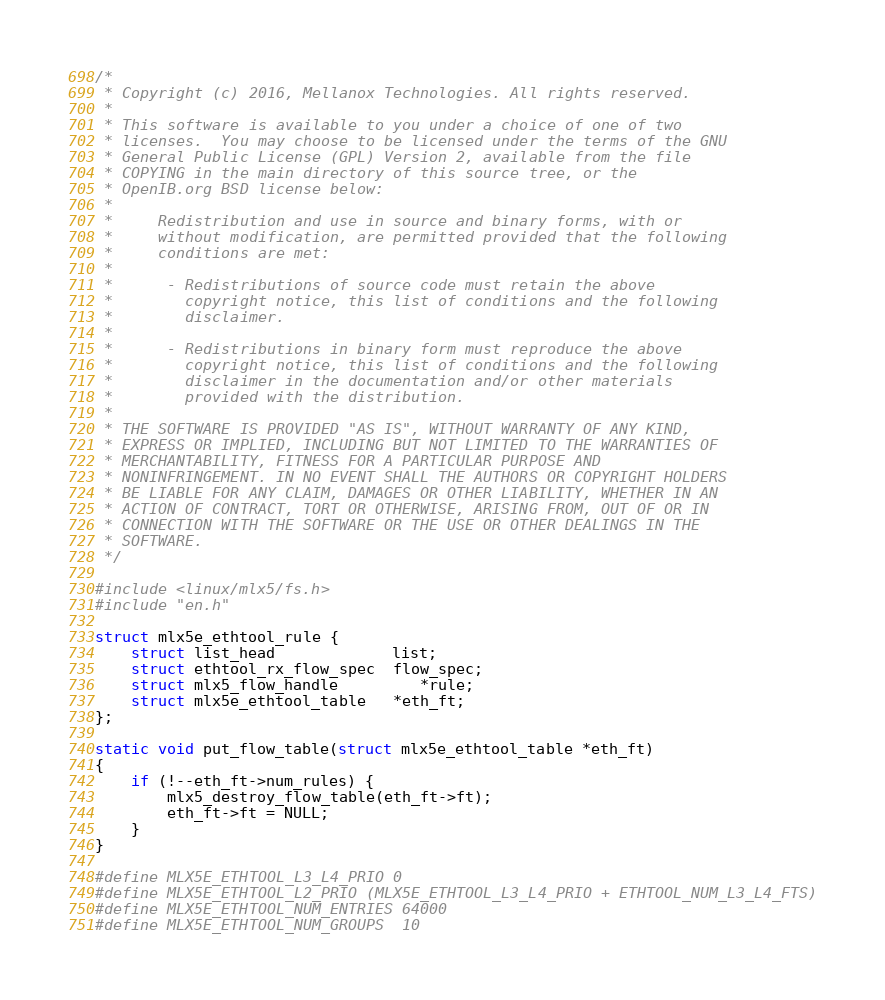Convert code to text. <code><loc_0><loc_0><loc_500><loc_500><_C_>/*
 * Copyright (c) 2016, Mellanox Technologies. All rights reserved.
 *
 * This software is available to you under a choice of one of two
 * licenses.  You may choose to be licensed under the terms of the GNU
 * General Public License (GPL) Version 2, available from the file
 * COPYING in the main directory of this source tree, or the
 * OpenIB.org BSD license below:
 *
 *     Redistribution and use in source and binary forms, with or
 *     without modification, are permitted provided that the following
 *     conditions are met:
 *
 *      - Redistributions of source code must retain the above
 *        copyright notice, this list of conditions and the following
 *        disclaimer.
 *
 *      - Redistributions in binary form must reproduce the above
 *        copyright notice, this list of conditions and the following
 *        disclaimer in the documentation and/or other materials
 *        provided with the distribution.
 *
 * THE SOFTWARE IS PROVIDED "AS IS", WITHOUT WARRANTY OF ANY KIND,
 * EXPRESS OR IMPLIED, INCLUDING BUT NOT LIMITED TO THE WARRANTIES OF
 * MERCHANTABILITY, FITNESS FOR A PARTICULAR PURPOSE AND
 * NONINFRINGEMENT. IN NO EVENT SHALL THE AUTHORS OR COPYRIGHT HOLDERS
 * BE LIABLE FOR ANY CLAIM, DAMAGES OR OTHER LIABILITY, WHETHER IN AN
 * ACTION OF CONTRACT, TORT OR OTHERWISE, ARISING FROM, OUT OF OR IN
 * CONNECTION WITH THE SOFTWARE OR THE USE OR OTHER DEALINGS IN THE
 * SOFTWARE.
 */

#include <linux/mlx5/fs.h>
#include "en.h"

struct mlx5e_ethtool_rule {
	struct list_head             list;
	struct ethtool_rx_flow_spec  flow_spec;
	struct mlx5_flow_handle	     *rule;
	struct mlx5e_ethtool_table   *eth_ft;
};

static void put_flow_table(struct mlx5e_ethtool_table *eth_ft)
{
	if (!--eth_ft->num_rules) {
		mlx5_destroy_flow_table(eth_ft->ft);
		eth_ft->ft = NULL;
	}
}

#define MLX5E_ETHTOOL_L3_L4_PRIO 0
#define MLX5E_ETHTOOL_L2_PRIO (MLX5E_ETHTOOL_L3_L4_PRIO + ETHTOOL_NUM_L3_L4_FTS)
#define MLX5E_ETHTOOL_NUM_ENTRIES 64000
#define MLX5E_ETHTOOL_NUM_GROUPS  10</code> 